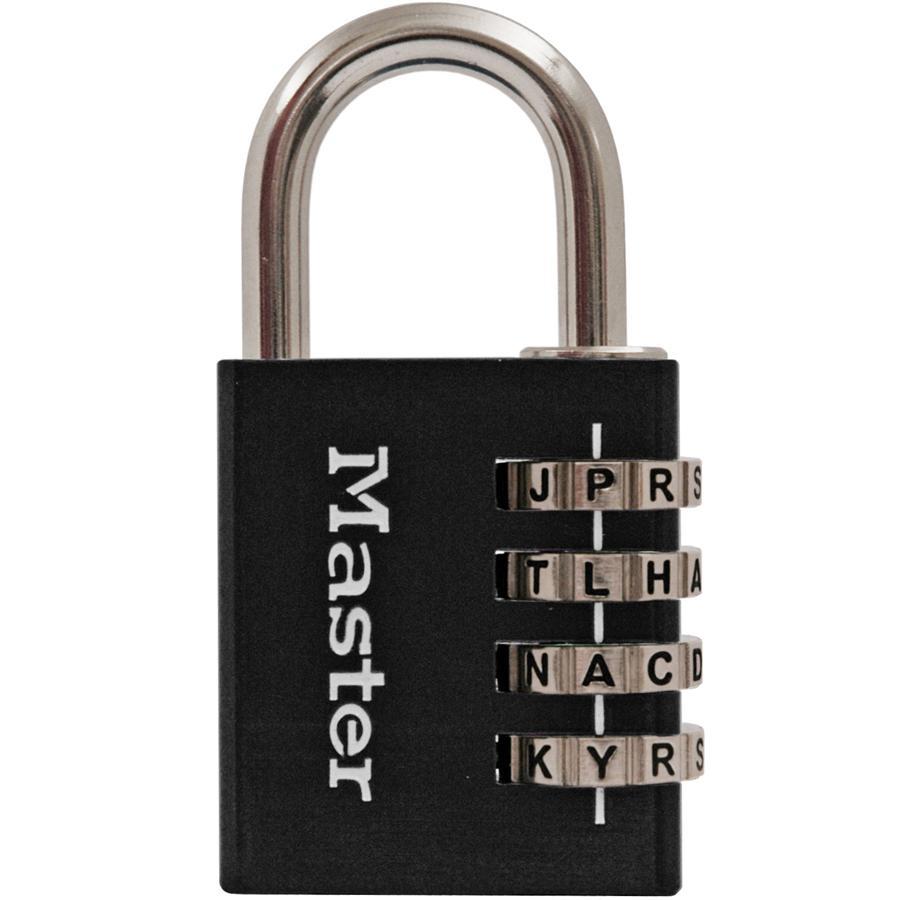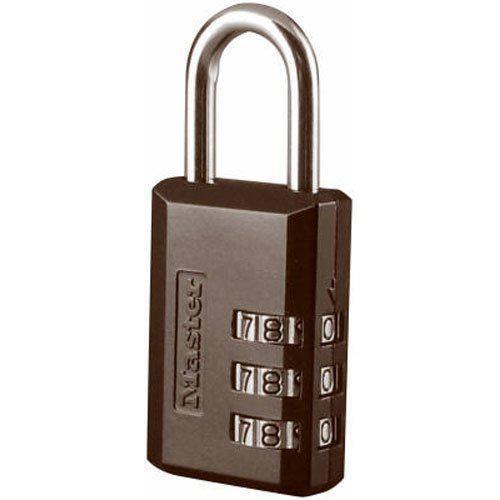The first image is the image on the left, the second image is the image on the right. For the images displayed, is the sentence "Two padlocks each have a different belt combination system and are different colors, but are both locked and have silver locking loops." factually correct? Answer yes or no. Yes. The first image is the image on the left, the second image is the image on the right. Evaluate the accuracy of this statement regarding the images: "Each lock is rectangular shaped, and one lock contains exactly three rows of numbers on wheels.". Is it true? Answer yes or no. Yes. 